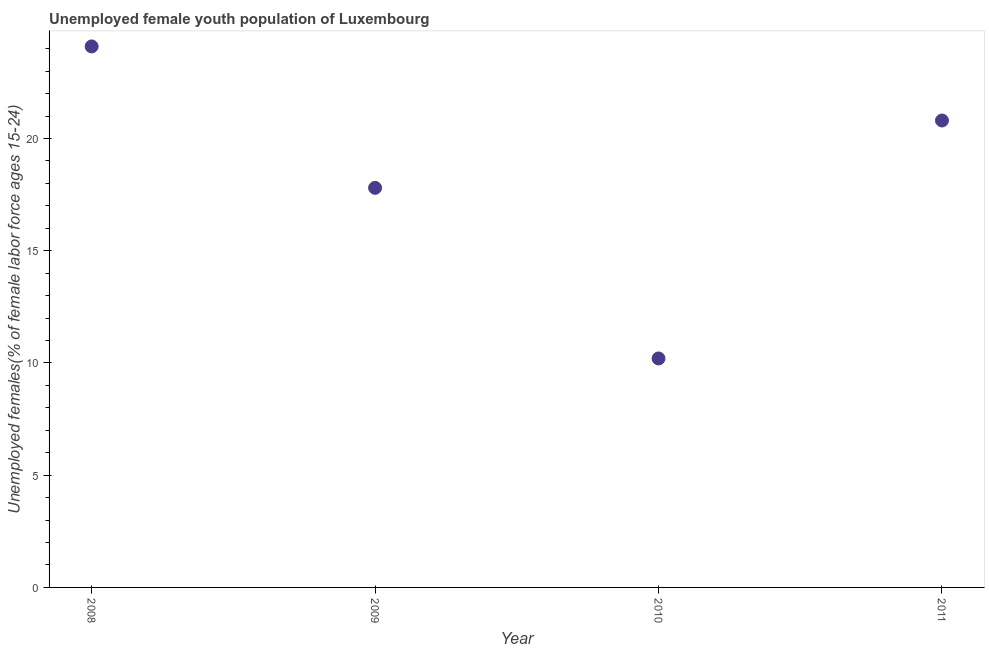What is the unemployed female youth in 2008?
Provide a succinct answer. 24.1. Across all years, what is the maximum unemployed female youth?
Provide a succinct answer. 24.1. Across all years, what is the minimum unemployed female youth?
Give a very brief answer. 10.2. In which year was the unemployed female youth maximum?
Ensure brevity in your answer.  2008. In which year was the unemployed female youth minimum?
Provide a short and direct response. 2010. What is the sum of the unemployed female youth?
Provide a short and direct response. 72.9. What is the difference between the unemployed female youth in 2010 and 2011?
Give a very brief answer. -10.6. What is the average unemployed female youth per year?
Provide a succinct answer. 18.22. What is the median unemployed female youth?
Keep it short and to the point. 19.3. In how many years, is the unemployed female youth greater than 19 %?
Provide a succinct answer. 2. Do a majority of the years between 2009 and 2008 (inclusive) have unemployed female youth greater than 12 %?
Ensure brevity in your answer.  No. What is the ratio of the unemployed female youth in 2009 to that in 2011?
Keep it short and to the point. 0.86. Is the unemployed female youth in 2009 less than that in 2011?
Your answer should be compact. Yes. What is the difference between the highest and the second highest unemployed female youth?
Make the answer very short. 3.3. Is the sum of the unemployed female youth in 2009 and 2010 greater than the maximum unemployed female youth across all years?
Your answer should be very brief. Yes. What is the difference between the highest and the lowest unemployed female youth?
Your answer should be very brief. 13.9. In how many years, is the unemployed female youth greater than the average unemployed female youth taken over all years?
Your response must be concise. 2. How many dotlines are there?
Keep it short and to the point. 1. What is the difference between two consecutive major ticks on the Y-axis?
Ensure brevity in your answer.  5. Does the graph contain any zero values?
Keep it short and to the point. No. What is the title of the graph?
Provide a succinct answer. Unemployed female youth population of Luxembourg. What is the label or title of the X-axis?
Provide a succinct answer. Year. What is the label or title of the Y-axis?
Your response must be concise. Unemployed females(% of female labor force ages 15-24). What is the Unemployed females(% of female labor force ages 15-24) in 2008?
Offer a very short reply. 24.1. What is the Unemployed females(% of female labor force ages 15-24) in 2009?
Provide a short and direct response. 17.8. What is the Unemployed females(% of female labor force ages 15-24) in 2010?
Your response must be concise. 10.2. What is the Unemployed females(% of female labor force ages 15-24) in 2011?
Your answer should be compact. 20.8. What is the difference between the Unemployed females(% of female labor force ages 15-24) in 2008 and 2009?
Keep it short and to the point. 6.3. What is the ratio of the Unemployed females(% of female labor force ages 15-24) in 2008 to that in 2009?
Provide a succinct answer. 1.35. What is the ratio of the Unemployed females(% of female labor force ages 15-24) in 2008 to that in 2010?
Make the answer very short. 2.36. What is the ratio of the Unemployed females(% of female labor force ages 15-24) in 2008 to that in 2011?
Provide a short and direct response. 1.16. What is the ratio of the Unemployed females(% of female labor force ages 15-24) in 2009 to that in 2010?
Your response must be concise. 1.75. What is the ratio of the Unemployed females(% of female labor force ages 15-24) in 2009 to that in 2011?
Ensure brevity in your answer.  0.86. What is the ratio of the Unemployed females(% of female labor force ages 15-24) in 2010 to that in 2011?
Your answer should be compact. 0.49. 